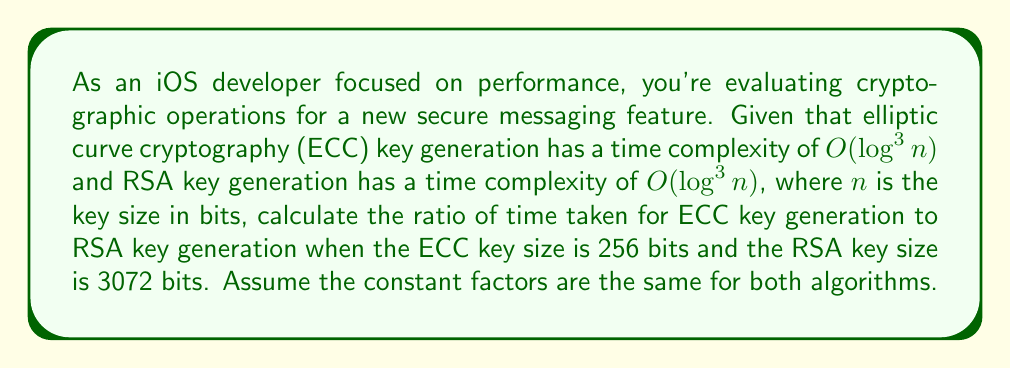What is the answer to this math problem? To solve this problem, we'll follow these steps:

1) The time complexity for both ECC and RSA key generation is $O(log^3 n)$, where $n$ is the key size in bits.

2) For ECC, $n_{ECC} = 256$ bits
   For RSA, $n_{RSA} = 3072$ bits

3) The ratio of time taken will be proportional to the ratio of their $log^3 n$ values:

   $$\frac{T_{ECC}}{T_{RSA}} = \frac{log^3(256)}{log^3(3072)}$$

4) Simplify:
   $$\frac{log^3(2^8)}{log^3(2^{12})} = \frac{8^3}{12^3} = \frac{512}{1728}$$

5) Reduce the fraction:
   $$\frac{512}{1728} = \frac{8}{27}$$

Therefore, the ratio of time taken for ECC key generation to RSA key generation is 8:27 or approximately 0.296:1.
Answer: $\frac{8}{27}$ 